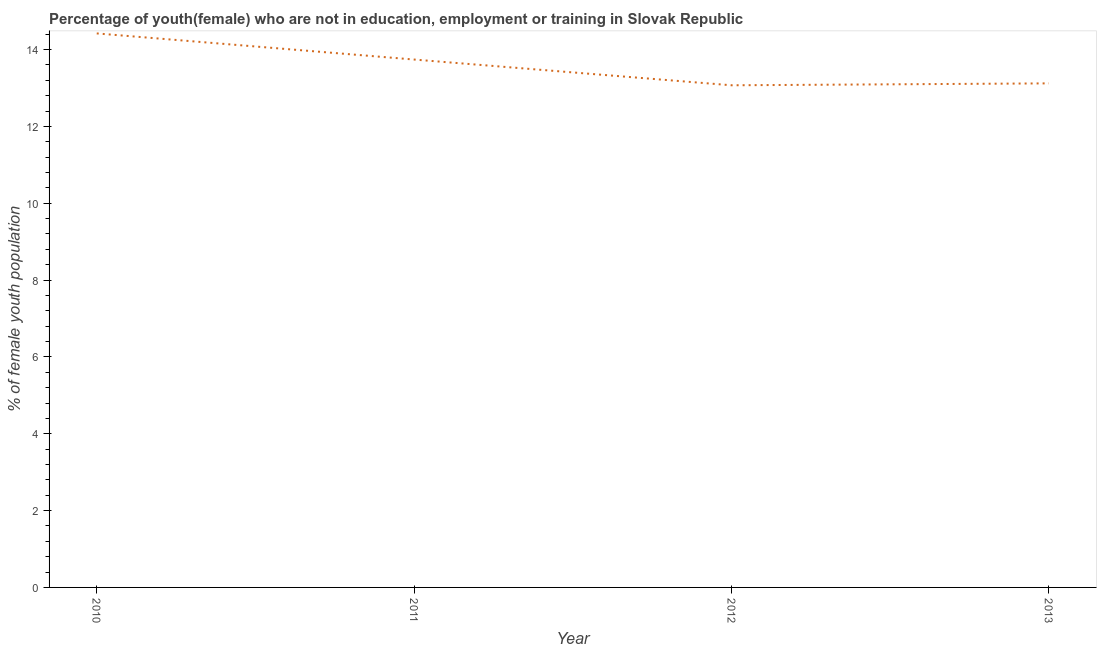What is the unemployed female youth population in 2013?
Offer a very short reply. 13.12. Across all years, what is the maximum unemployed female youth population?
Your response must be concise. 14.42. Across all years, what is the minimum unemployed female youth population?
Keep it short and to the point. 13.07. In which year was the unemployed female youth population maximum?
Provide a short and direct response. 2010. What is the sum of the unemployed female youth population?
Your answer should be compact. 54.35. What is the difference between the unemployed female youth population in 2012 and 2013?
Ensure brevity in your answer.  -0.05. What is the average unemployed female youth population per year?
Make the answer very short. 13.59. What is the median unemployed female youth population?
Provide a succinct answer. 13.43. In how many years, is the unemployed female youth population greater than 13.2 %?
Provide a succinct answer. 2. What is the ratio of the unemployed female youth population in 2011 to that in 2012?
Keep it short and to the point. 1.05. Is the unemployed female youth population in 2010 less than that in 2012?
Your answer should be very brief. No. What is the difference between the highest and the second highest unemployed female youth population?
Offer a very short reply. 0.68. What is the difference between the highest and the lowest unemployed female youth population?
Give a very brief answer. 1.35. How many lines are there?
Your response must be concise. 1. What is the title of the graph?
Keep it short and to the point. Percentage of youth(female) who are not in education, employment or training in Slovak Republic. What is the label or title of the X-axis?
Keep it short and to the point. Year. What is the label or title of the Y-axis?
Provide a short and direct response. % of female youth population. What is the % of female youth population in 2010?
Offer a very short reply. 14.42. What is the % of female youth population in 2011?
Your answer should be very brief. 13.74. What is the % of female youth population of 2012?
Provide a short and direct response. 13.07. What is the % of female youth population of 2013?
Keep it short and to the point. 13.12. What is the difference between the % of female youth population in 2010 and 2011?
Give a very brief answer. 0.68. What is the difference between the % of female youth population in 2010 and 2012?
Ensure brevity in your answer.  1.35. What is the difference between the % of female youth population in 2010 and 2013?
Provide a succinct answer. 1.3. What is the difference between the % of female youth population in 2011 and 2012?
Provide a short and direct response. 0.67. What is the difference between the % of female youth population in 2011 and 2013?
Give a very brief answer. 0.62. What is the difference between the % of female youth population in 2012 and 2013?
Keep it short and to the point. -0.05. What is the ratio of the % of female youth population in 2010 to that in 2011?
Your answer should be compact. 1.05. What is the ratio of the % of female youth population in 2010 to that in 2012?
Provide a short and direct response. 1.1. What is the ratio of the % of female youth population in 2010 to that in 2013?
Provide a succinct answer. 1.1. What is the ratio of the % of female youth population in 2011 to that in 2012?
Ensure brevity in your answer.  1.05. What is the ratio of the % of female youth population in 2011 to that in 2013?
Offer a terse response. 1.05. What is the ratio of the % of female youth population in 2012 to that in 2013?
Make the answer very short. 1. 